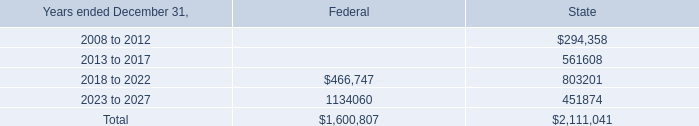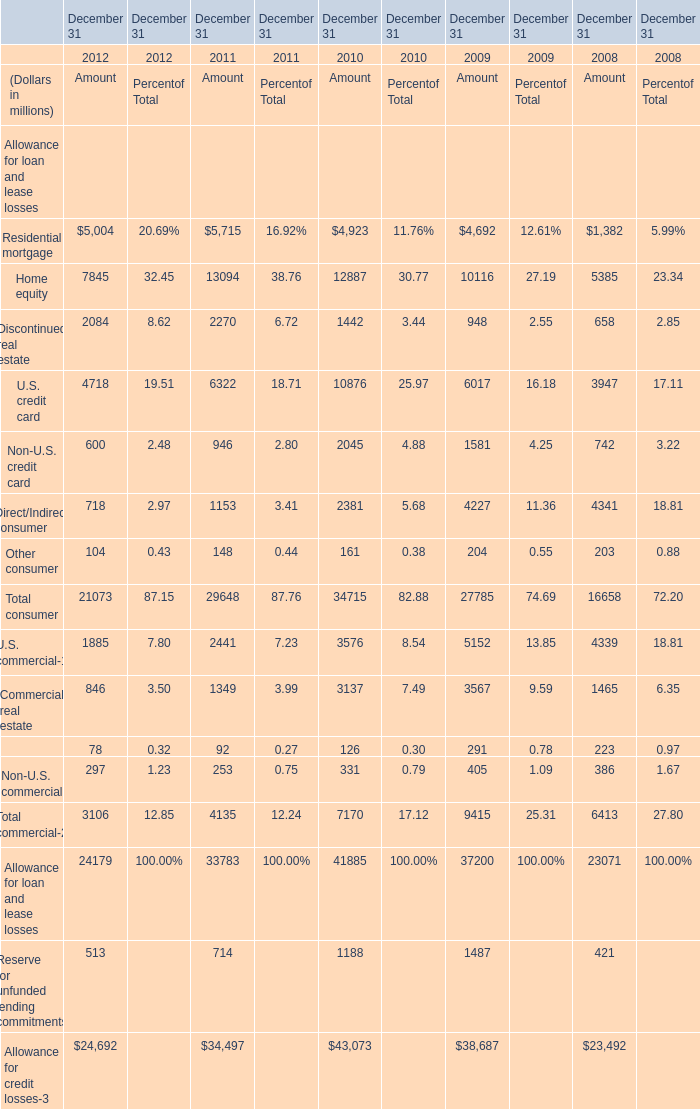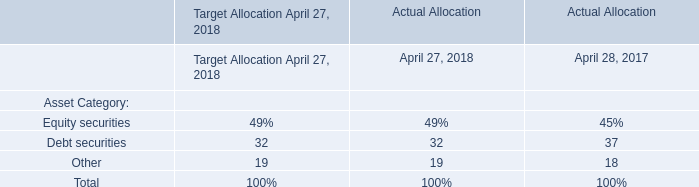What was the total amount of Total consumer for Amount in 2012 ? (in million) 
Computations: ((((((5004 + 7845) + 2084) + 4718) + 600) + 718) + 104)
Answer: 21073.0. 